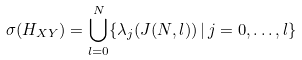Convert formula to latex. <formula><loc_0><loc_0><loc_500><loc_500>\sigma ( H _ { X Y } ) = \bigcup _ { l = 0 } ^ { N } \{ \lambda _ { j } ( J ( N , l ) ) \, | \, j = 0 , \dots , l \}</formula> 